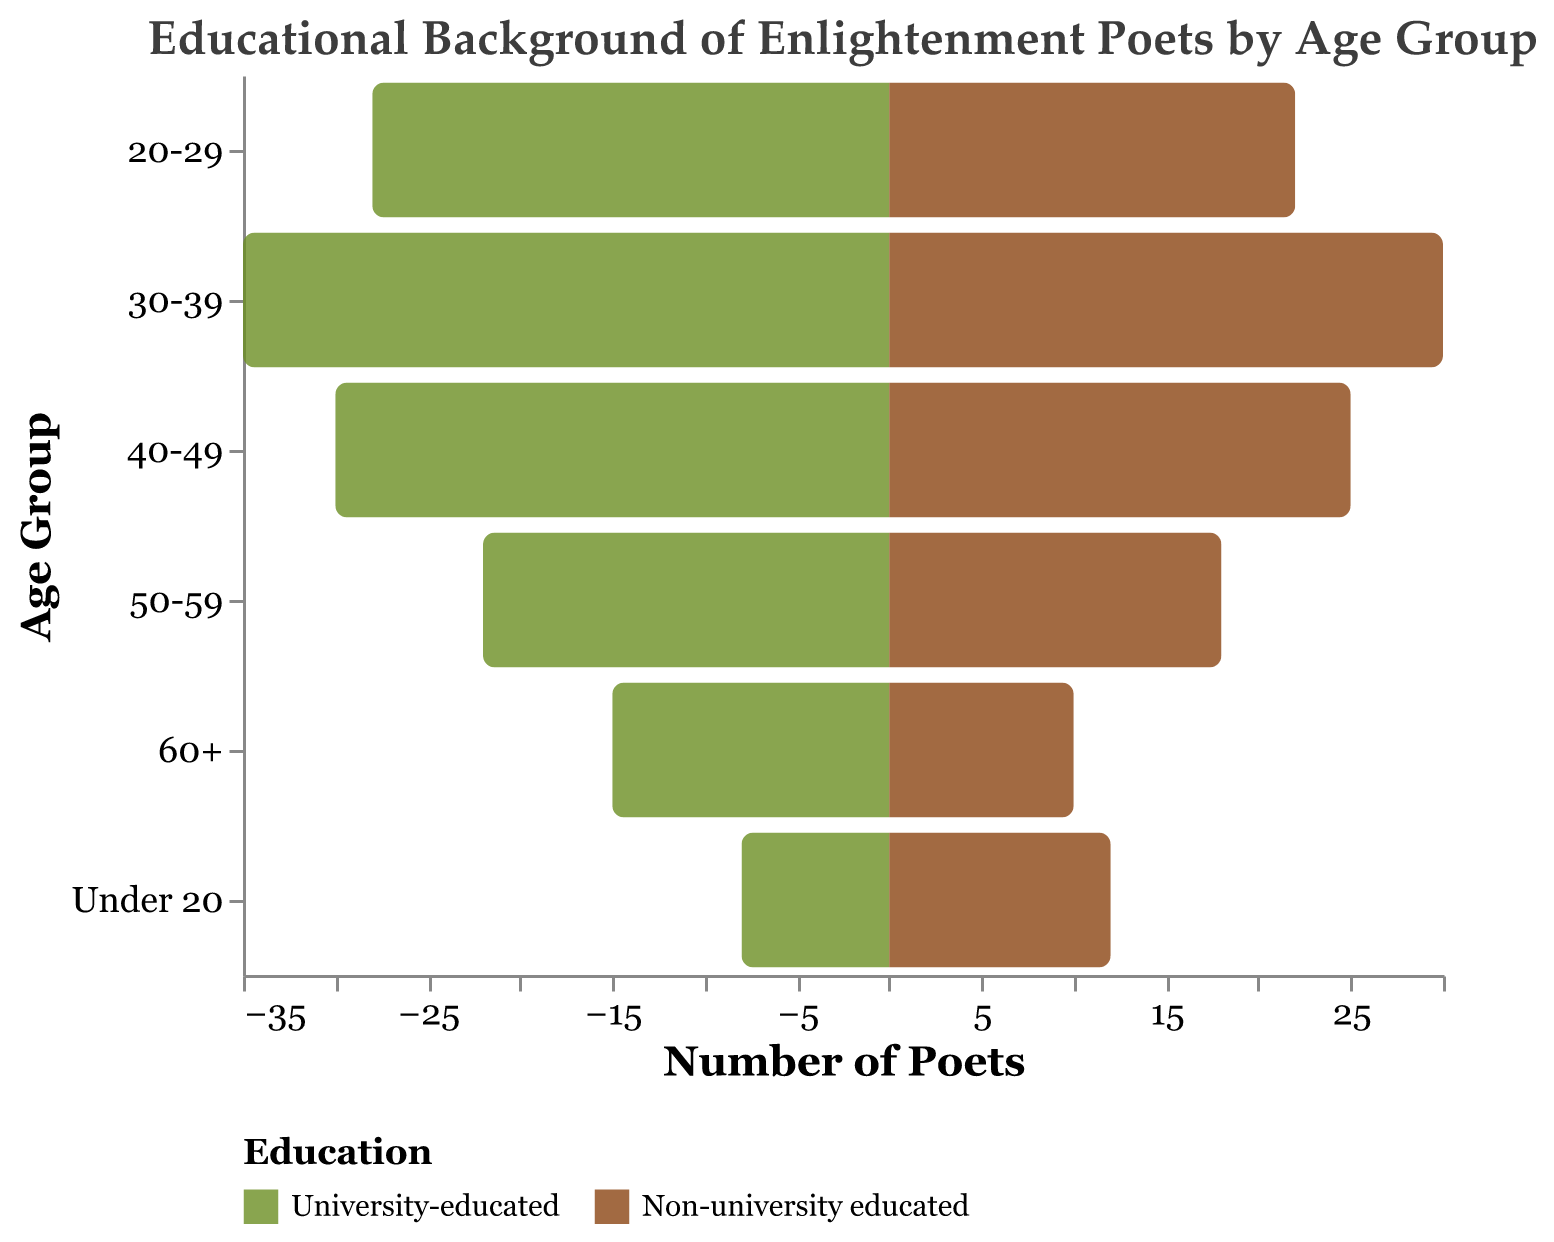What's the title of the figure? The title of the figure is displayed at the top as "Educational Background of Enlightenment Poets by Age Group".
Answer: Educational Background of Enlightenment Poets by Age Group Which age group has the largest number of university-educated poets? To determine the age group with the largest number of university-educated poets, compare the University-educated values across all age groups. The group "30-39" has 35 university-educated poets, which is the highest.
Answer: 30-39 How many poets under the age of 20 are university-educated? Look at the "University-educated" column for the "Under 20" age group, which shows a value of 8 poets.
Answer: 8 In the 40-49 age group, how many more university-educated poets are there compared to non-university educated ones? Subtract the number of Non-university educated poets from the University-educated poets for the 40-49 age group: 30 - 25 = 5.
Answer: 5 Which age group has more non-university educated poets than university-educated ones? Compare the values of university-educated and non-university educated poets in each age group. The "Under 20" group has more non-university educated poets (12) than university-educated poets (8).
Answer: Under 20 What is the total number of university-educated poets across all age groups? Sum the University-educated values across all age groups: 15 + 22 + 30 + 35 + 28 + 8 = 138.
Answer: 138 How many poets aged 60+ are included in the figure? Add the University-educated and Non-university educated values for the 60+ age group: 15 + 10 = 25.
Answer: 25 Between the age groups 50-59 and 20-29, which one has a higher total number of poets? Calculate the total poets for both groups. For 50-59: 22 + 18 = 40. For 20-29: 28 + 22 = 50. Compare the sums to find that 20-29 has a higher total.
Answer: 20-29 What is the overall trend of university education among poets as age increases? Observe how the number of university-educated poets changes across age groups. Younger age groups (30-39 and 20-29) have higher numbers, which generally decline with age.
Answer: Decline What is the difference between the total number of poets aged 30-39 and those aged 40-49? Calculate the totals for both age groups and then find the difference. For 30-39: 35 + 30 = 65. For 40-49: 30 + 25 = 55. Difference is 65 - 55 = 10.
Answer: 10 